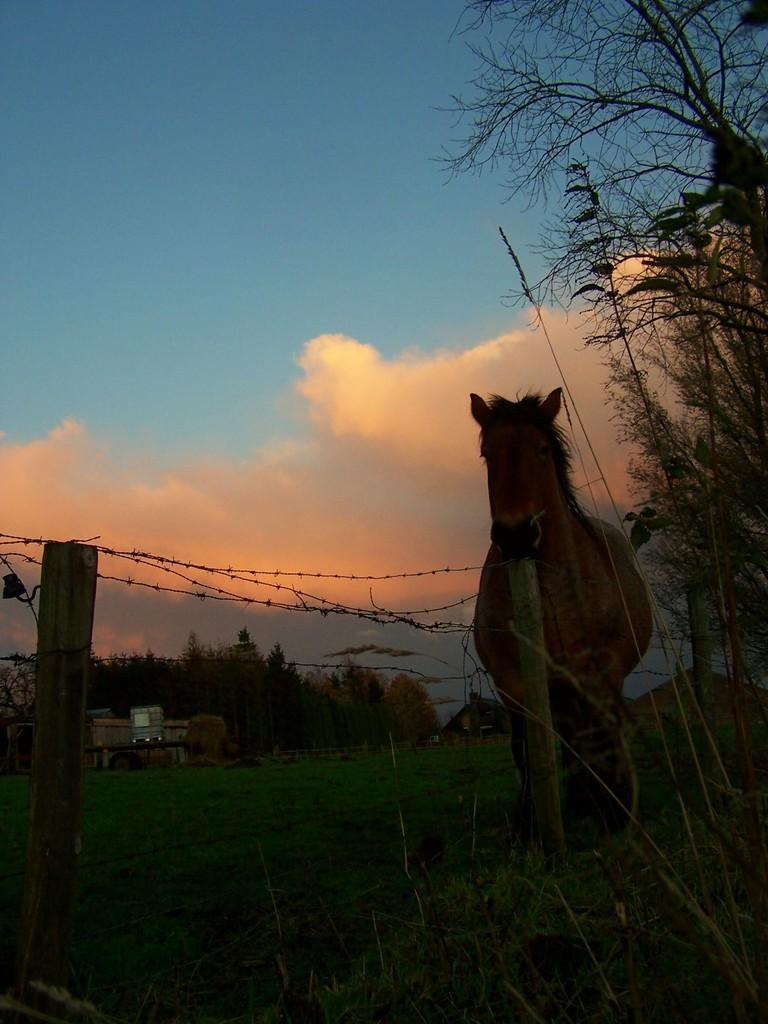What animal is present in the image? There is a horse in the image. Where is the horse located in relation to the pole fencing? The horse is standing near a pole fencing. What type of vegetation can be seen at the bottom of the image? Grass is visible at the bottom of the image. What other types of vegetation are present in the image? There are plants in the image. What can be seen in the background of the image? There are trees and a house in the background of the image. How would you describe the sky in the background of the image? The sky is cloudy in the background of the image. What type of whistle is the horse using to communicate with the bears in the image? There are no bears or whistles present in the image; it features a horse standing near a pole fencing with grass, plants, trees, a house, and a cloudy sky in the background. 